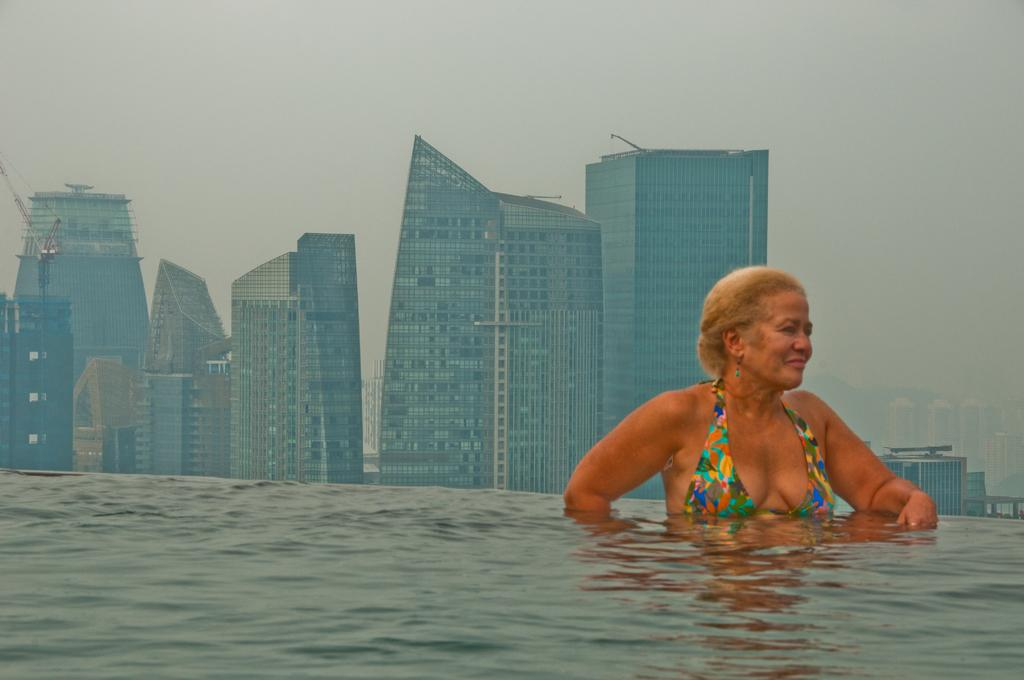What is at the bottom of the image? There is water at the bottom of the image. Who or what is in the water? A woman is in the water. What can be seen in the distance behind the woman? There are buildings visible in the background. What else is visible in the background? The sky is visible in the background. How does the woman ask for help in the image? There is no indication in the image that the woman is asking for help, so it cannot be determined from the picture. 